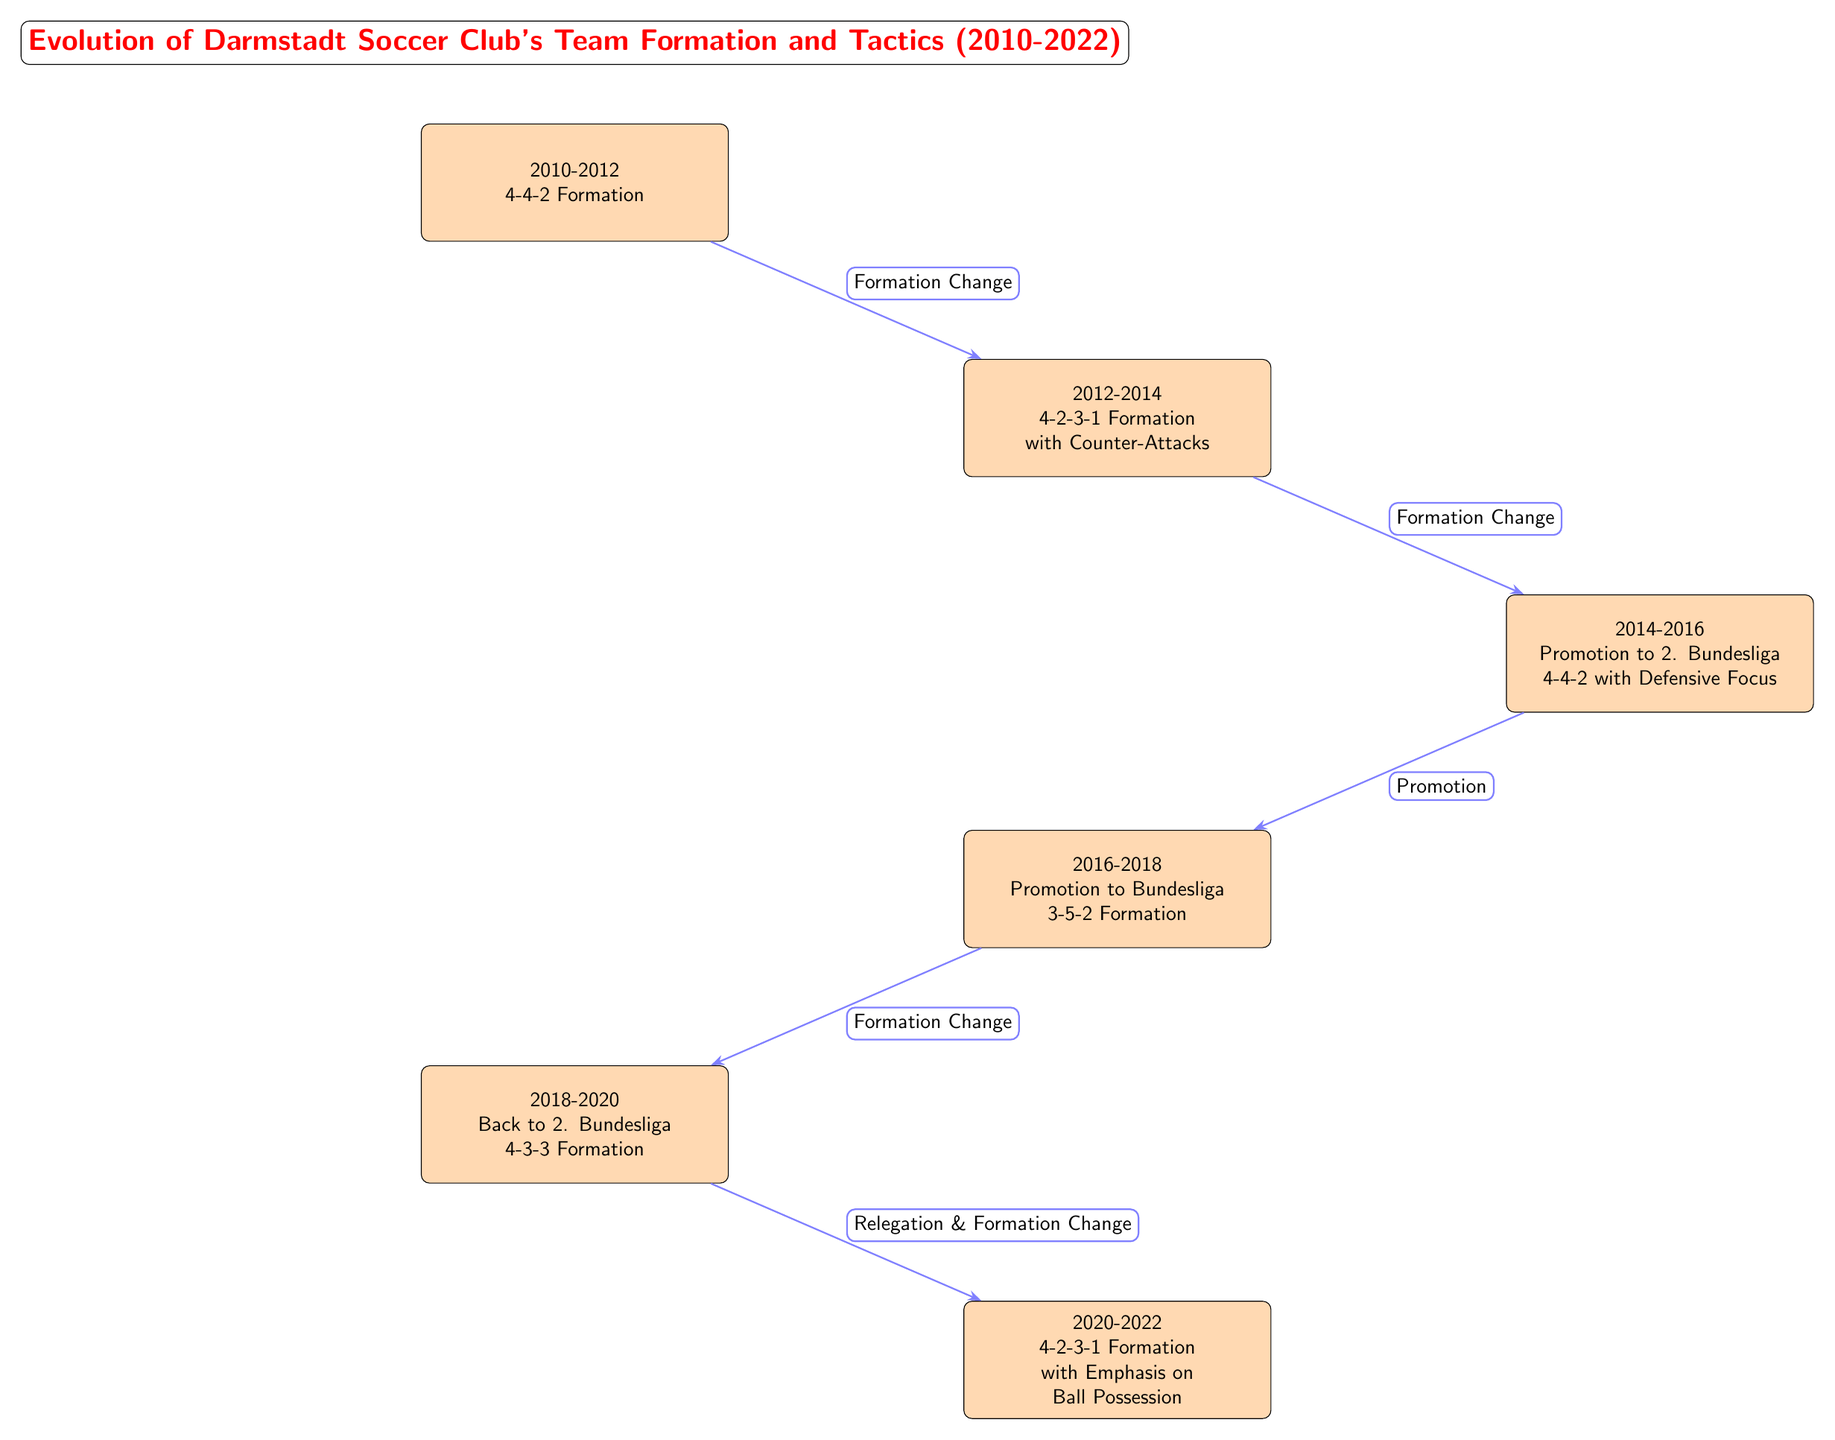What was the initial formation of Darmstadt Soccer Club in 2010? The diagram indicates that the initial formation was a 4-4-2 Formation. This can be seen directly from the first node labeled "2010-2012".
Answer: 4-4-2 Formation How many distinct formations did Darmstadt Soccer Club use from 2010 to 2022? By counting the distinct formations shown in each event from the diagram, we see that there are five formations used throughout the timeline.
Answer: 5 What was the team formation during the promotion to Bundesliga in 2016? Referring to the node titled "2016-2018", it shows that the formation during the promotion to Bundesliga was the 3-5-2 Formation.
Answer: 3-5-2 Formation What event led to the formation change in 2018? According to the diagram, the formation change in 2018 was preceded by the event labeled "Relegation & Formation Change" that connects the nodes for 2018 and 2020.
Answer: Relegation Which formation was utilized in the 2020-2022 period? The final node for the period 2020-2022 shows that the utilized formation was the 4-2-3-1 Formation with an emphasis on ball possession. This information is clearly stated in that node.
Answer: 4-2-3-1 Formation What was the main tactical focus during the 4-2-3-1 formation from 2020 to 2022? Looking at the details in the node for 2020-2022, it explicitly mentions "with Emphasis on Ball Possession" as the tactical focus during this formation.
Answer: Ball Possession What was the time span for the 4-4-2 formation? The diagram shows that the 4-4-2 formation was used from 2010 to 2012, as indicated in the node "2010-2012".
Answer: 2010-2012 Which two formations were used consecutively in 2014 and 2016? The diagram shows that in 2014 the formation was a 4-4-2 with a Defensive Focus, and in 2016 it changed to a 3-5-2 Formation. This connection can be traced through the nodes from 2014 to 2016.
Answer: 4-4-2 and 3-5-2 